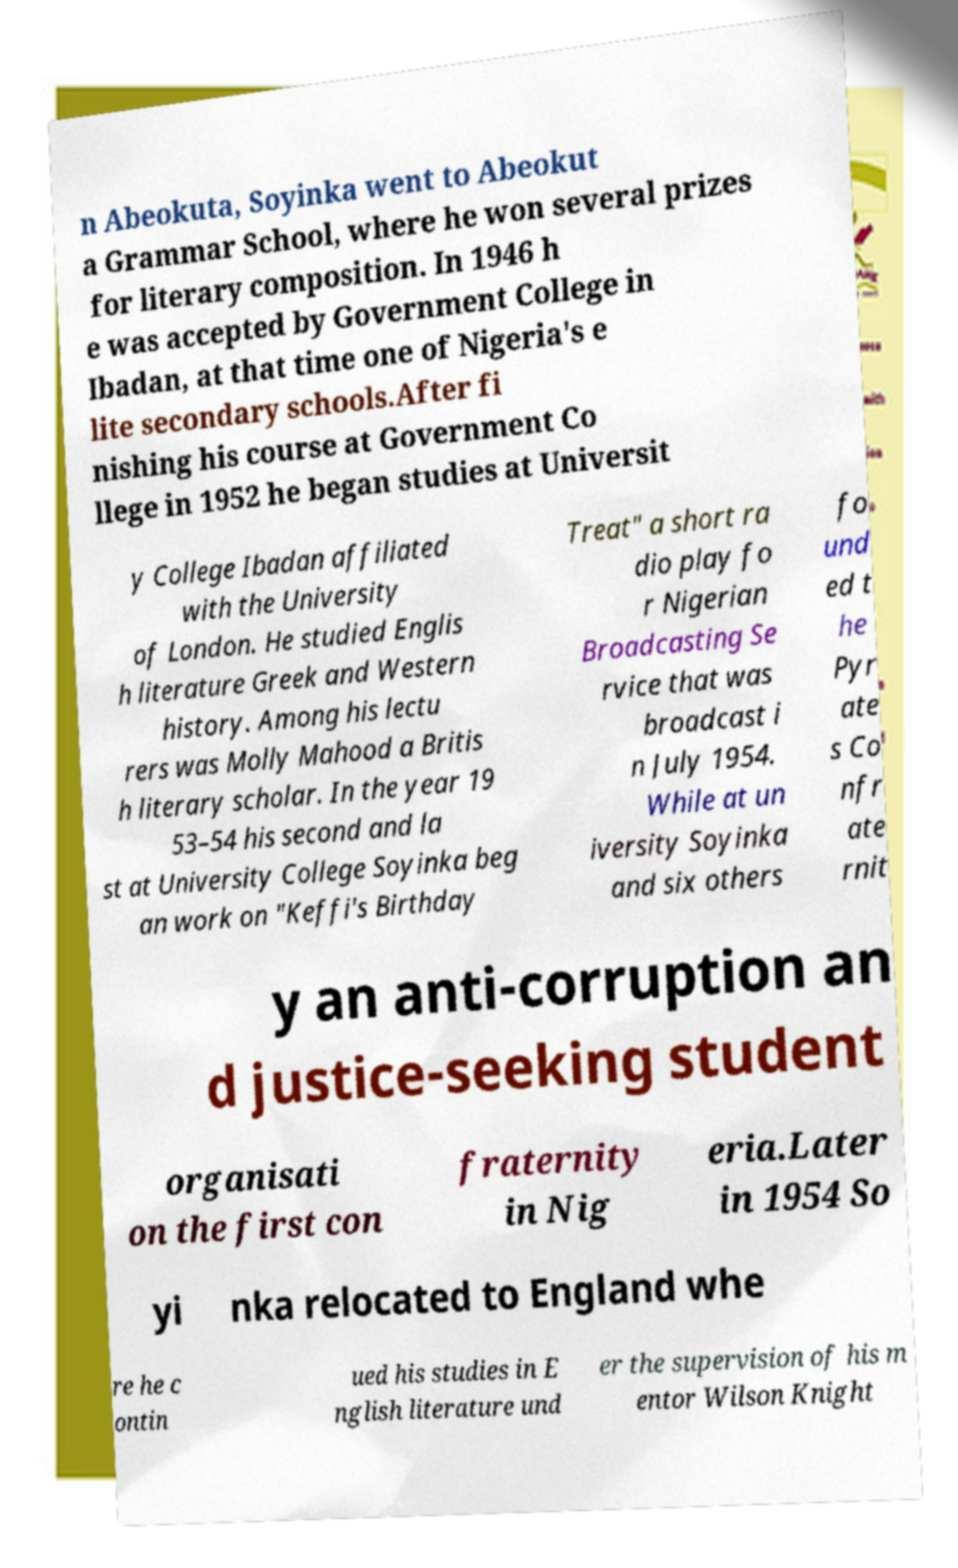Can you accurately transcribe the text from the provided image for me? n Abeokuta, Soyinka went to Abeokut a Grammar School, where he won several prizes for literary composition. In 1946 h e was accepted by Government College in Ibadan, at that time one of Nigeria's e lite secondary schools.After fi nishing his course at Government Co llege in 1952 he began studies at Universit y College Ibadan affiliated with the University of London. He studied Englis h literature Greek and Western history. Among his lectu rers was Molly Mahood a Britis h literary scholar. In the year 19 53–54 his second and la st at University College Soyinka beg an work on "Keffi's Birthday Treat" a short ra dio play fo r Nigerian Broadcasting Se rvice that was broadcast i n July 1954. While at un iversity Soyinka and six others fo und ed t he Pyr ate s Co nfr ate rnit y an anti-corruption an d justice-seeking student organisati on the first con fraternity in Nig eria.Later in 1954 So yi nka relocated to England whe re he c ontin ued his studies in E nglish literature und er the supervision of his m entor Wilson Knight 